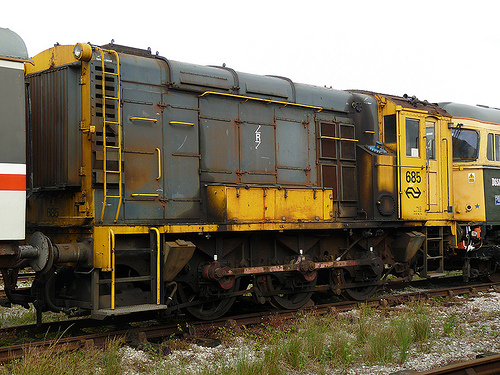On which side is the ladder? The ladder is on the left side of the train car in the image. 